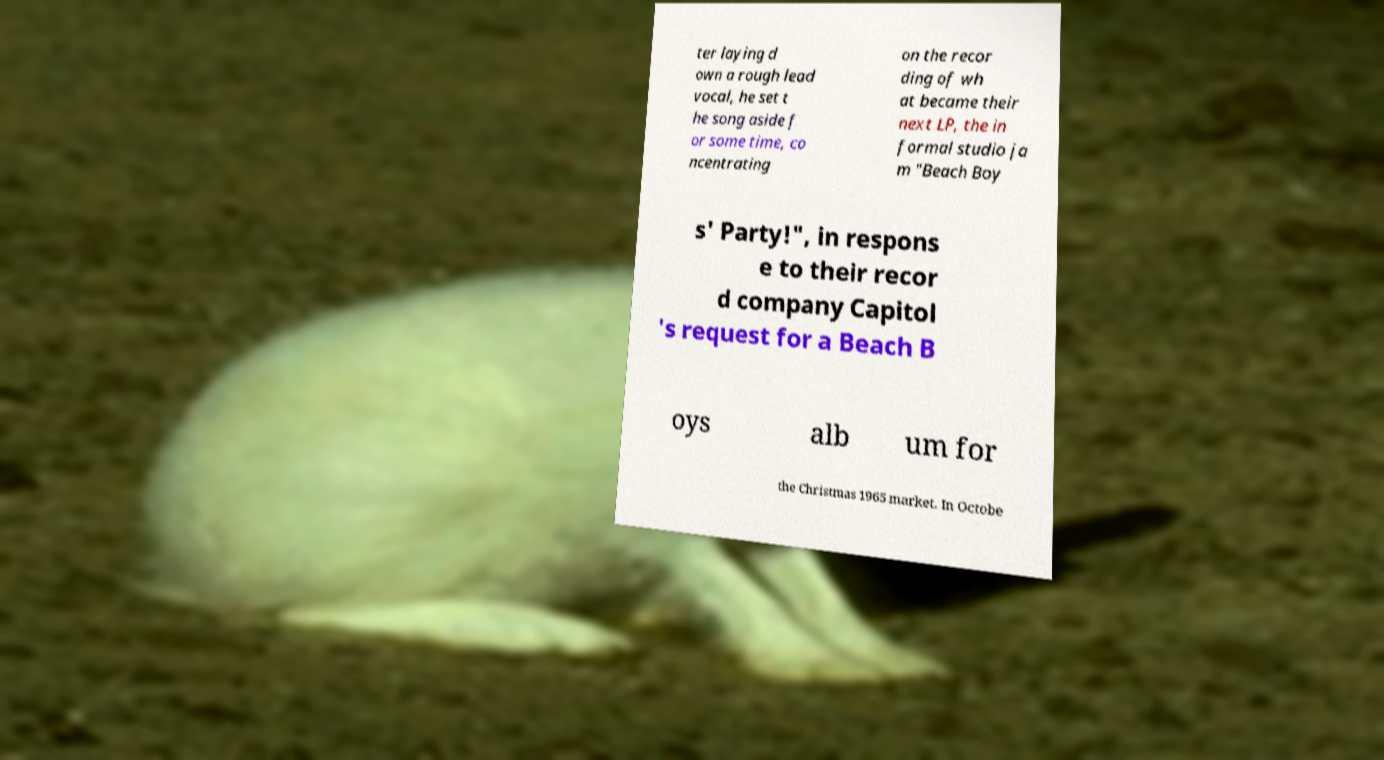Could you extract and type out the text from this image? ter laying d own a rough lead vocal, he set t he song aside f or some time, co ncentrating on the recor ding of wh at became their next LP, the in formal studio ja m "Beach Boy s' Party!", in respons e to their recor d company Capitol 's request for a Beach B oys alb um for the Christmas 1965 market. In Octobe 